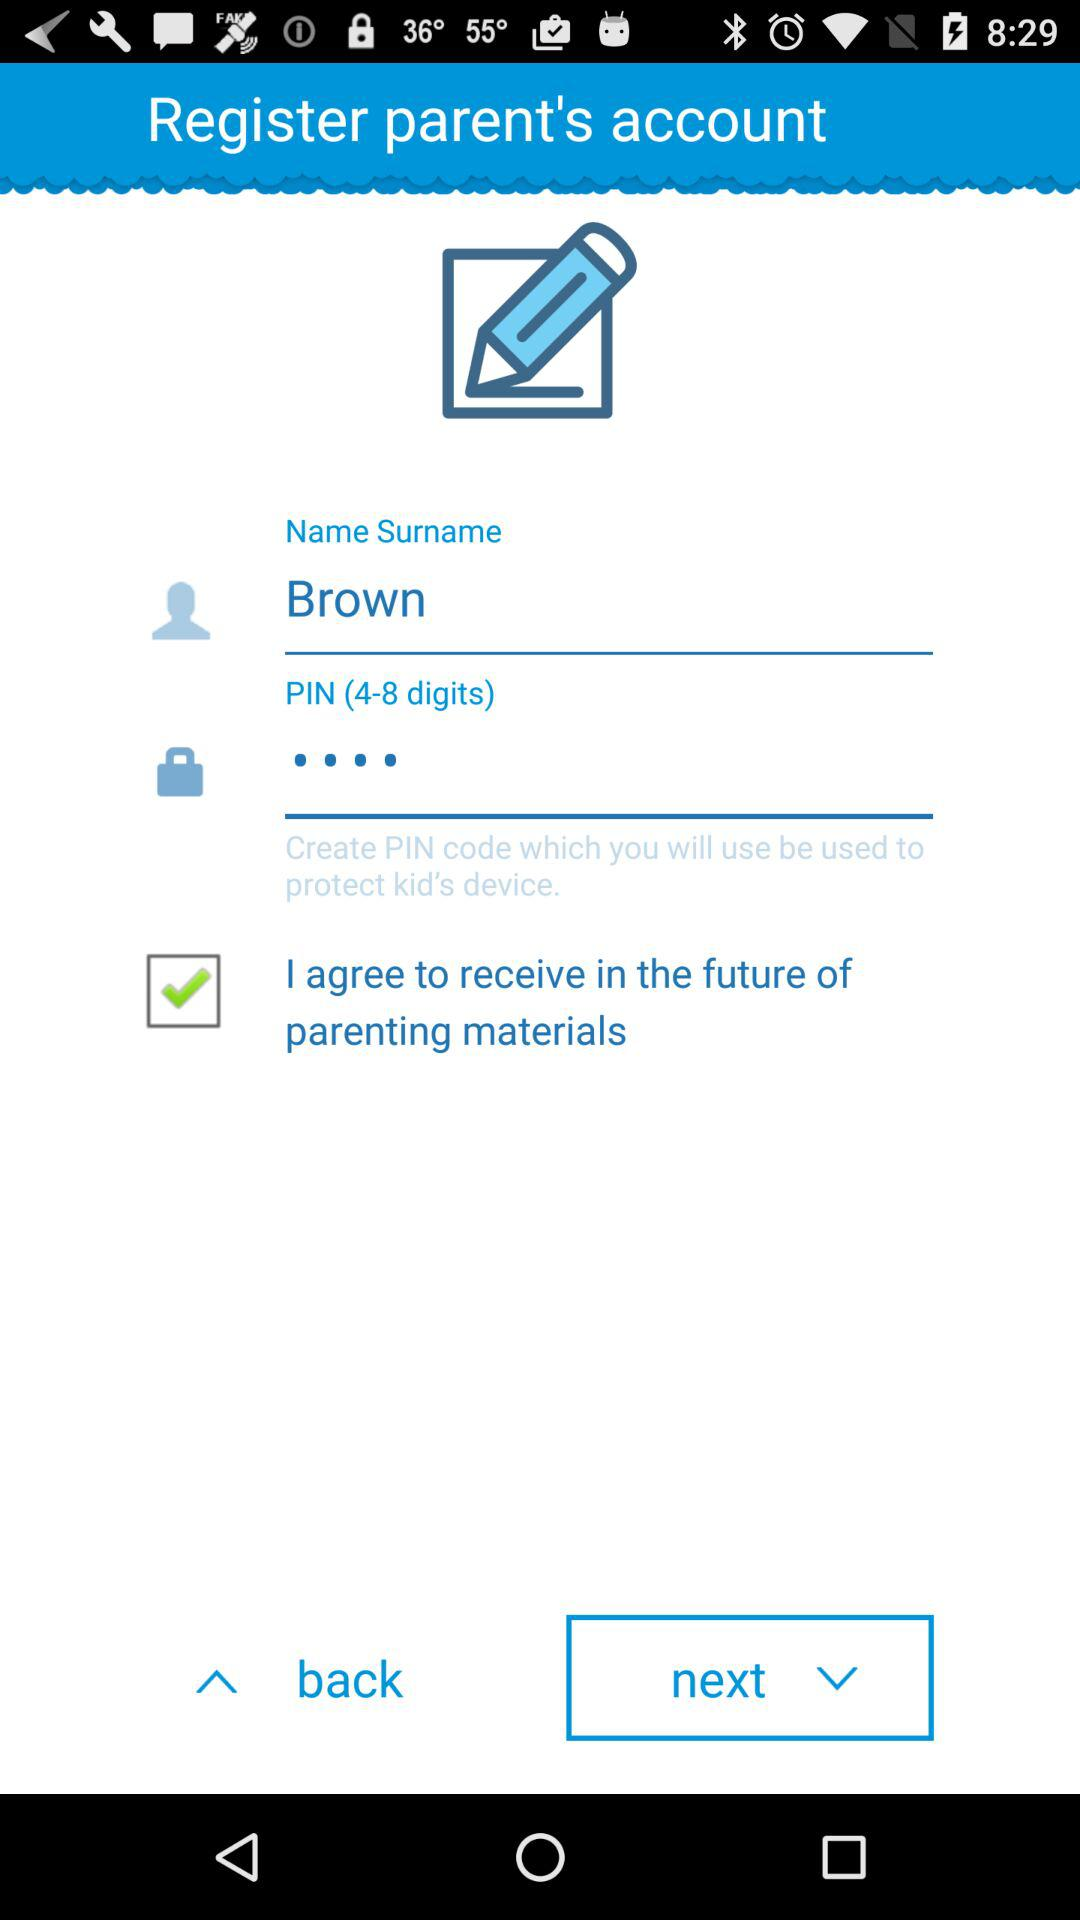What should be the length of the PIN? The length of the PIN should be 4 to 8 digits. 